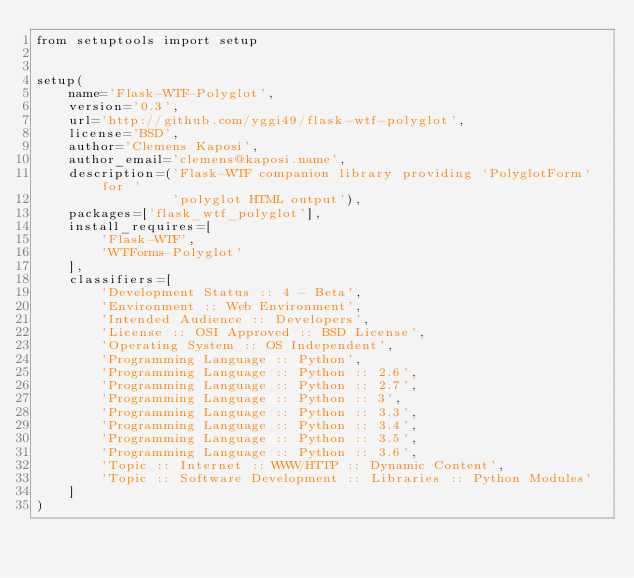Convert code to text. <code><loc_0><loc_0><loc_500><loc_500><_Python_>from setuptools import setup


setup(
    name='Flask-WTF-Polyglot',
    version='0.3',
    url='http://github.com/yggi49/flask-wtf-polyglot',
    license='BSD',
    author='Clemens Kaposi',
    author_email='clemens@kaposi.name',
    description=('Flask-WTF companion library providing `PolyglotForm` for '
                 'polyglot HTML output'),
    packages=['flask_wtf_polyglot'],
    install_requires=[
        'Flask-WTF',
        'WTForms-Polyglot'
    ],
    classifiers=[
        'Development Status :: 4 - Beta',
        'Environment :: Web Environment',
        'Intended Audience :: Developers',
        'License :: OSI Approved :: BSD License',
        'Operating System :: OS Independent',
        'Programming Language :: Python',
        'Programming Language :: Python :: 2.6',
        'Programming Language :: Python :: 2.7',
        'Programming Language :: Python :: 3',
        'Programming Language :: Python :: 3.3',
        'Programming Language :: Python :: 3.4',
        'Programming Language :: Python :: 3.5',
        'Programming Language :: Python :: 3.6',
        'Topic :: Internet :: WWW/HTTP :: Dynamic Content',
        'Topic :: Software Development :: Libraries :: Python Modules'
    ]
)
</code> 